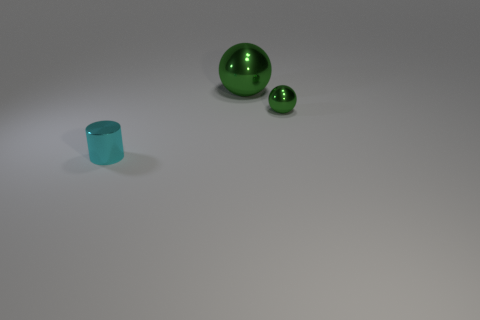Add 3 small things. How many objects exist? 6 Subtract all cylinders. How many objects are left? 2 Add 2 green balls. How many green balls are left? 4 Add 3 big things. How many big things exist? 4 Subtract 0 yellow blocks. How many objects are left? 3 Subtract all small matte objects. Subtract all tiny metallic cylinders. How many objects are left? 2 